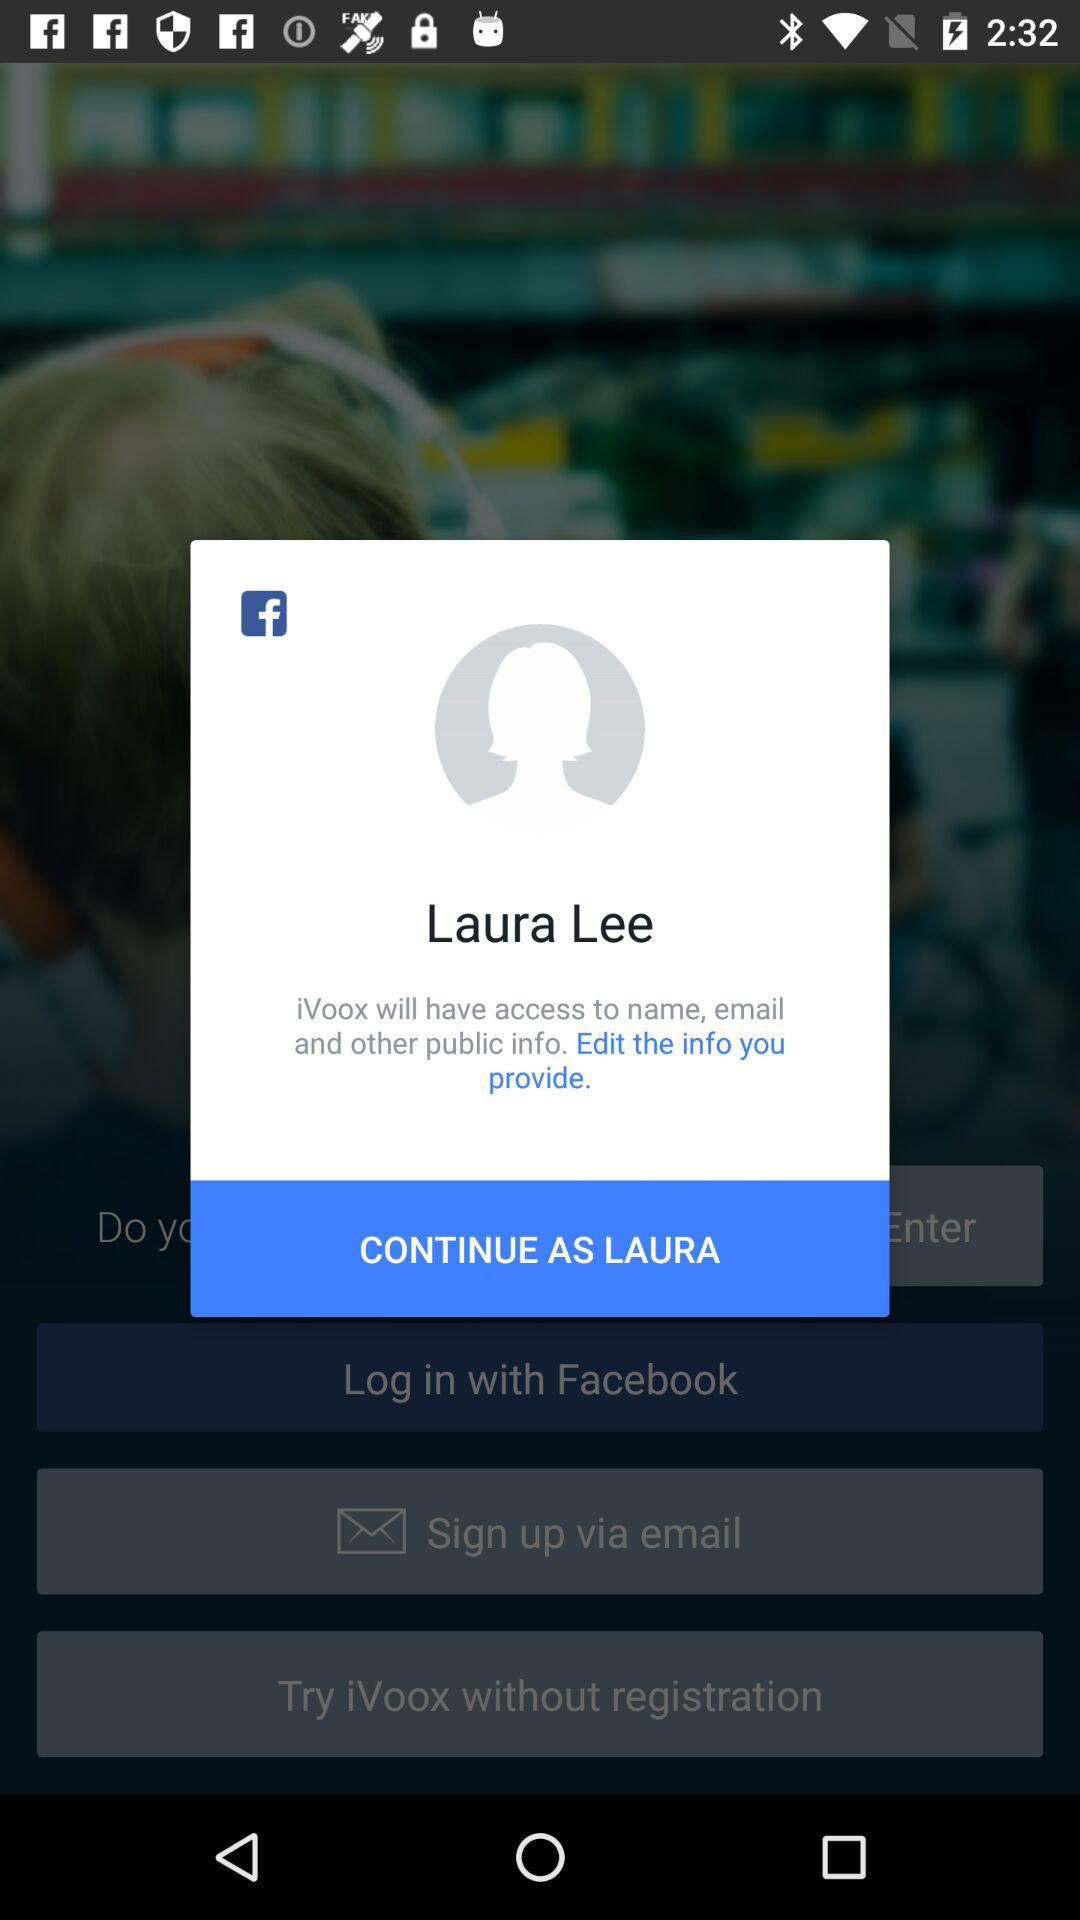With what profile name can the user continue? The user can continue with Laura. 